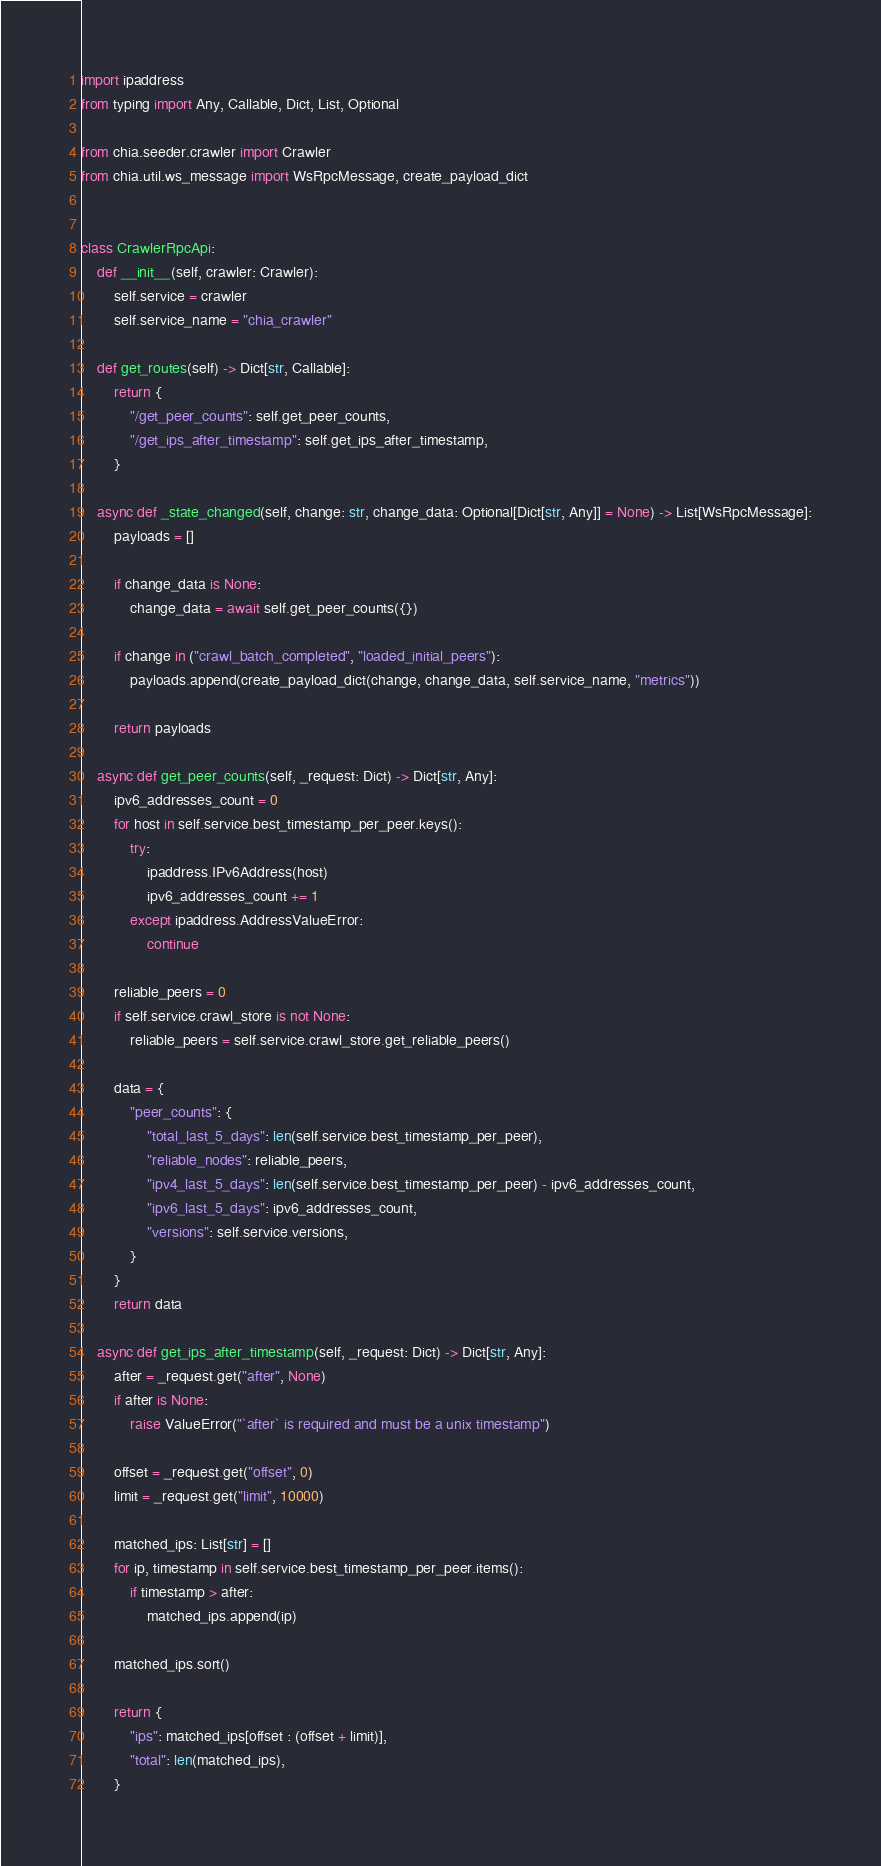Convert code to text. <code><loc_0><loc_0><loc_500><loc_500><_Python_>import ipaddress
from typing import Any, Callable, Dict, List, Optional

from chia.seeder.crawler import Crawler
from chia.util.ws_message import WsRpcMessage, create_payload_dict


class CrawlerRpcApi:
    def __init__(self, crawler: Crawler):
        self.service = crawler
        self.service_name = "chia_crawler"

    def get_routes(self) -> Dict[str, Callable]:
        return {
            "/get_peer_counts": self.get_peer_counts,
            "/get_ips_after_timestamp": self.get_ips_after_timestamp,
        }

    async def _state_changed(self, change: str, change_data: Optional[Dict[str, Any]] = None) -> List[WsRpcMessage]:
        payloads = []

        if change_data is None:
            change_data = await self.get_peer_counts({})

        if change in ("crawl_batch_completed", "loaded_initial_peers"):
            payloads.append(create_payload_dict(change, change_data, self.service_name, "metrics"))

        return payloads

    async def get_peer_counts(self, _request: Dict) -> Dict[str, Any]:
        ipv6_addresses_count = 0
        for host in self.service.best_timestamp_per_peer.keys():
            try:
                ipaddress.IPv6Address(host)
                ipv6_addresses_count += 1
            except ipaddress.AddressValueError:
                continue

        reliable_peers = 0
        if self.service.crawl_store is not None:
            reliable_peers = self.service.crawl_store.get_reliable_peers()

        data = {
            "peer_counts": {
                "total_last_5_days": len(self.service.best_timestamp_per_peer),
                "reliable_nodes": reliable_peers,
                "ipv4_last_5_days": len(self.service.best_timestamp_per_peer) - ipv6_addresses_count,
                "ipv6_last_5_days": ipv6_addresses_count,
                "versions": self.service.versions,
            }
        }
        return data

    async def get_ips_after_timestamp(self, _request: Dict) -> Dict[str, Any]:
        after = _request.get("after", None)
        if after is None:
            raise ValueError("`after` is required and must be a unix timestamp")

        offset = _request.get("offset", 0)
        limit = _request.get("limit", 10000)

        matched_ips: List[str] = []
        for ip, timestamp in self.service.best_timestamp_per_peer.items():
            if timestamp > after:
                matched_ips.append(ip)

        matched_ips.sort()

        return {
            "ips": matched_ips[offset : (offset + limit)],
            "total": len(matched_ips),
        }
</code> 